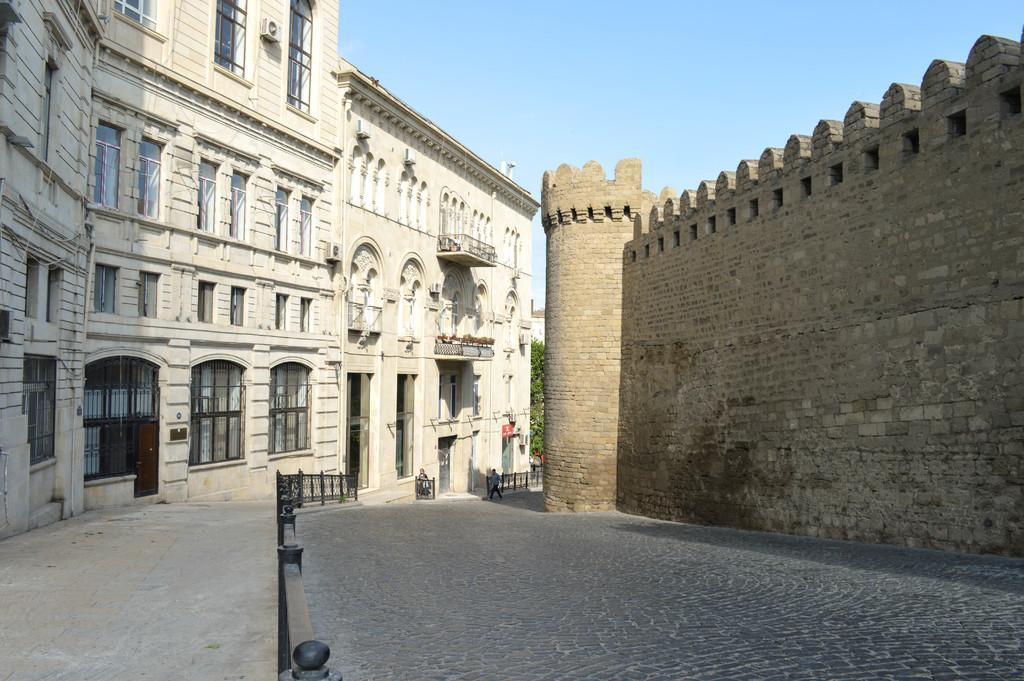What type of path can be seen in the image? There is a footpath in the image. What is located alongside the footpath? There is a road in the image. What structures are present in the image? There are buildings in the image. What architectural features can be seen on the buildings? There are windows and walls visible on the buildings. What natural elements are present in the image? There are trees in the image. How many people are in the image? There are two people in the image. What else can be seen in the image? There are some objects in the image. What is visible in the background of the image? The sky is visible in the background of the image. What type of plate is being used for the discussion in the image? There is no plate or discussion present in the image. What is the position of the sun in the image? The sun is not visible in the image; only the sky is visible in the background. 